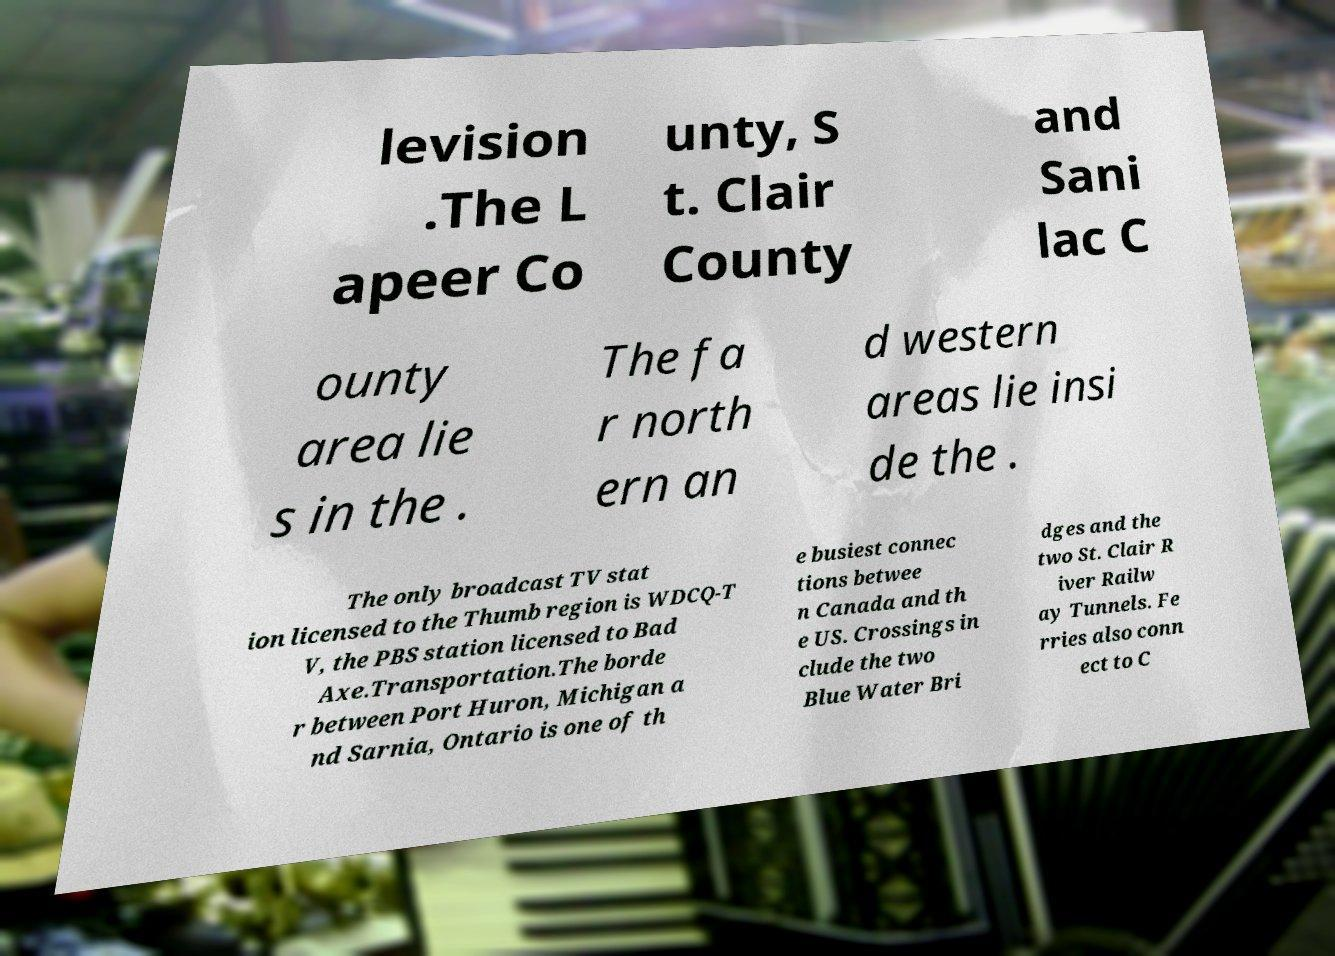Can you read and provide the text displayed in the image?This photo seems to have some interesting text. Can you extract and type it out for me? levision .The L apeer Co unty, S t. Clair County and Sani lac C ounty area lie s in the . The fa r north ern an d western areas lie insi de the . The only broadcast TV stat ion licensed to the Thumb region is WDCQ-T V, the PBS station licensed to Bad Axe.Transportation.The borde r between Port Huron, Michigan a nd Sarnia, Ontario is one of th e busiest connec tions betwee n Canada and th e US. Crossings in clude the two Blue Water Bri dges and the two St. Clair R iver Railw ay Tunnels. Fe rries also conn ect to C 